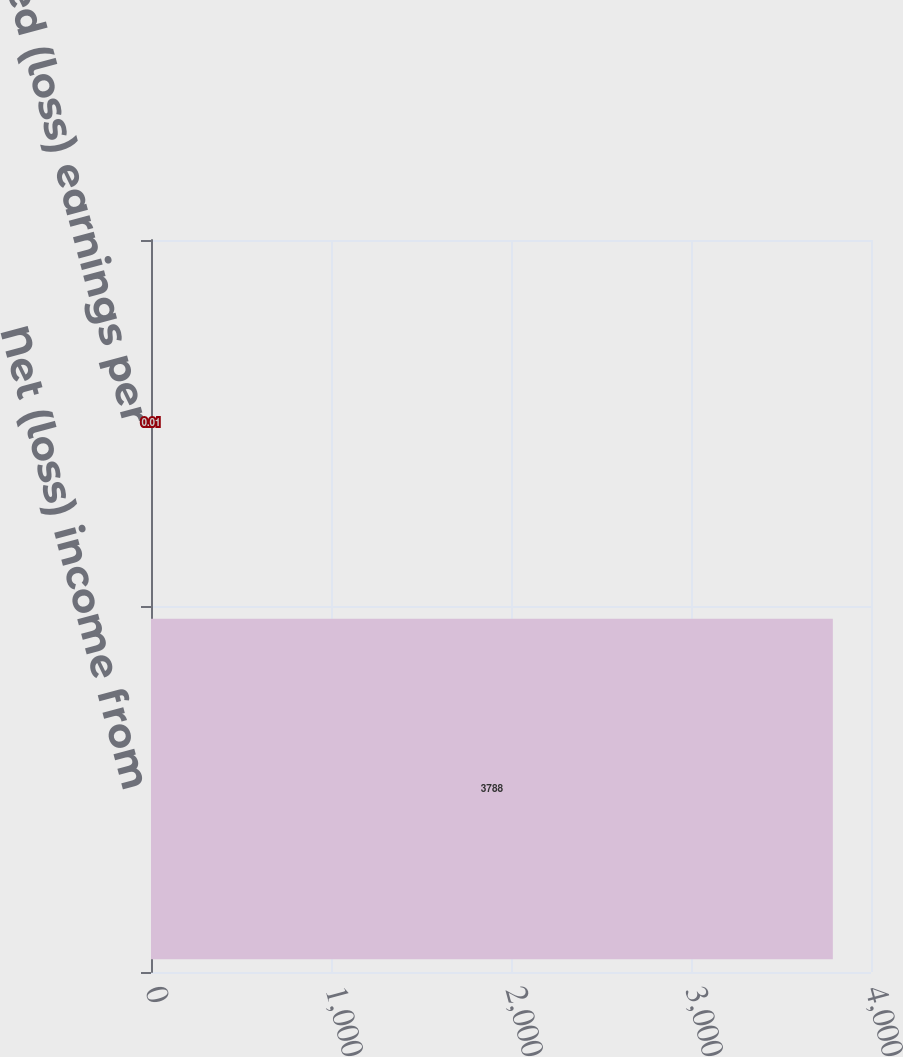Convert chart. <chart><loc_0><loc_0><loc_500><loc_500><bar_chart><fcel>Net (loss) income from<fcel>Diluted (loss) earnings per<nl><fcel>3788<fcel>0.01<nl></chart> 